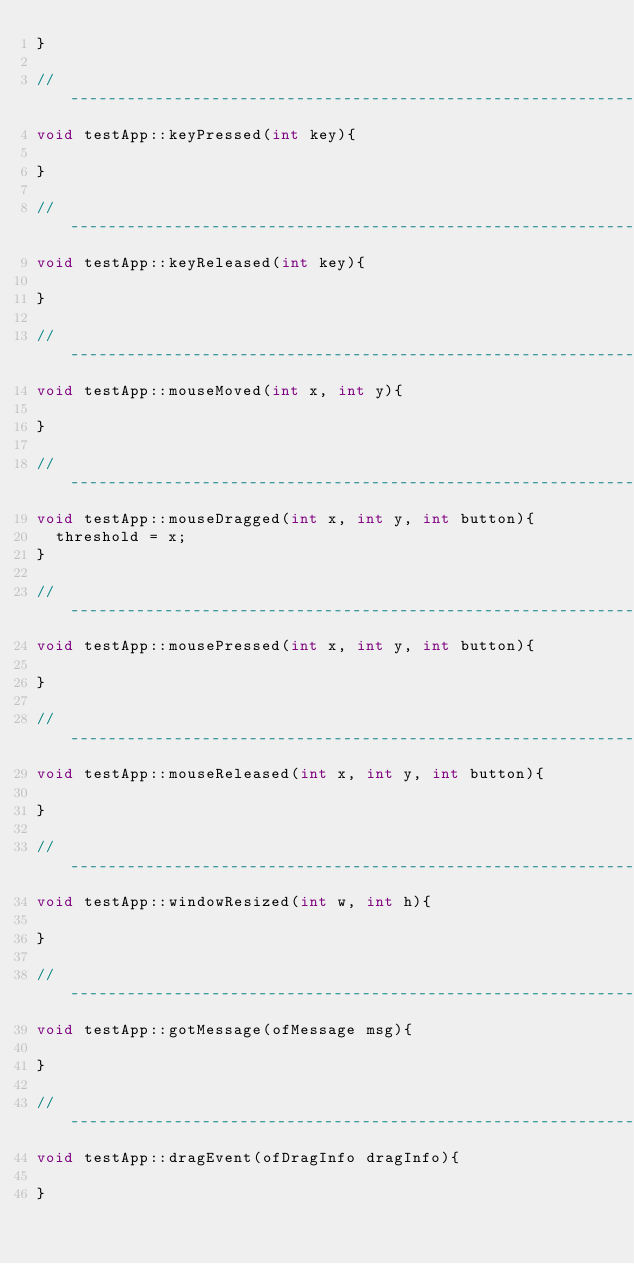<code> <loc_0><loc_0><loc_500><loc_500><_C++_>}

//--------------------------------------------------------------
void testApp::keyPressed(int key){

}

//--------------------------------------------------------------
void testApp::keyReleased(int key){

}

//--------------------------------------------------------------
void testApp::mouseMoved(int x, int y){

}

//--------------------------------------------------------------
void testApp::mouseDragged(int x, int y, int button){
	threshold = x;
}

//--------------------------------------------------------------
void testApp::mousePressed(int x, int y, int button){

}

//--------------------------------------------------------------
void testApp::mouseReleased(int x, int y, int button){

}

//--------------------------------------------------------------
void testApp::windowResized(int w, int h){

}

//--------------------------------------------------------------
void testApp::gotMessage(ofMessage msg){

}

//--------------------------------------------------------------
void testApp::dragEvent(ofDragInfo dragInfo){ 

}
</code> 